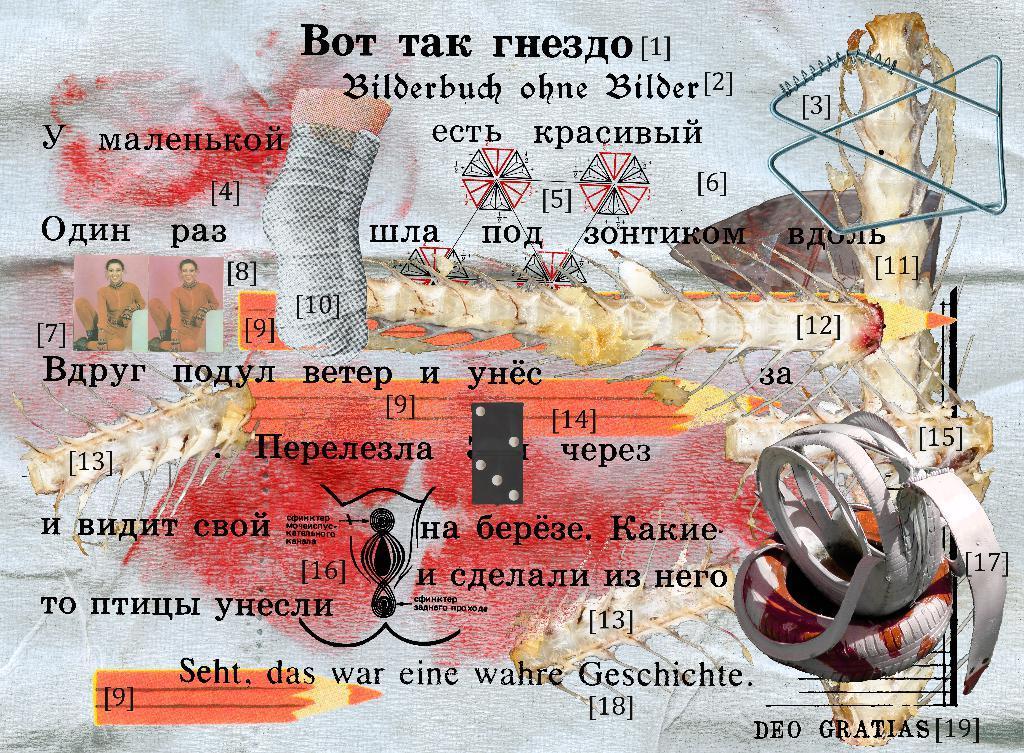Can you describe this image briefly? In this picture there is a poster. On the left there are some photos of a person were attached on the poster. In the bottom right I can see some some designed objects. 